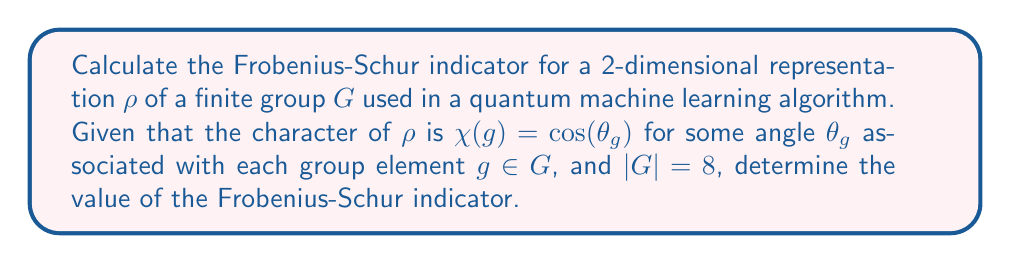Give your solution to this math problem. Let's approach this step-by-step:

1) The Frobenius-Schur indicator $\nu(\rho)$ for a representation $\rho$ of a finite group $G$ is given by:

   $$\nu(\rho) = \frac{1}{|G|} \sum_{g \in G} \chi(g^2)$$

2) In this case, we have $|G| = 8$ and $\chi(g) = \cos(\theta_g)$.

3) We need to calculate $\chi(g^2)$ for each $g \in G$. Note that $(g^2)$ is also an element of $G$, so $\chi(g^2) = \cos(\theta_{g^2})$.

4) Using the double angle formula for cosine:

   $$\cos(2\theta) = 2\cos^2(\theta) - 1$$

5) We can rewrite $\chi(g^2)$ as:

   $$\chi(g^2) = \cos(\theta_{g^2}) = \cos(2\theta_g) = 2\cos^2(\theta_g) - 1 = 2\chi(g)^2 - 1$$

6) Substituting this into the Frobenius-Schur indicator formula:

   $$\nu(\rho) = \frac{1}{8} \sum_{g \in G} (2\chi(g)^2 - 1)$$

7) This can be rewritten as:

   $$\nu(\rho) = \frac{1}{4} \sum_{g \in G} \chi(g)^2 - 1$$

8) The sum $\sum_{g \in G} \chi(g)^2$ is a well-known quantity in representation theory. For any irreducible representation of a finite group, it equals $|G|$. Since our representation is 2-dimensional and real-valued, it must be irreducible.

9) Therefore:

   $$\nu(\rho) = \frac{1}{4} \cdot 8 - 1 = 2 - 1 = 1$$

This result indicates that the representation is orthogonal (real).
Answer: $1$ 